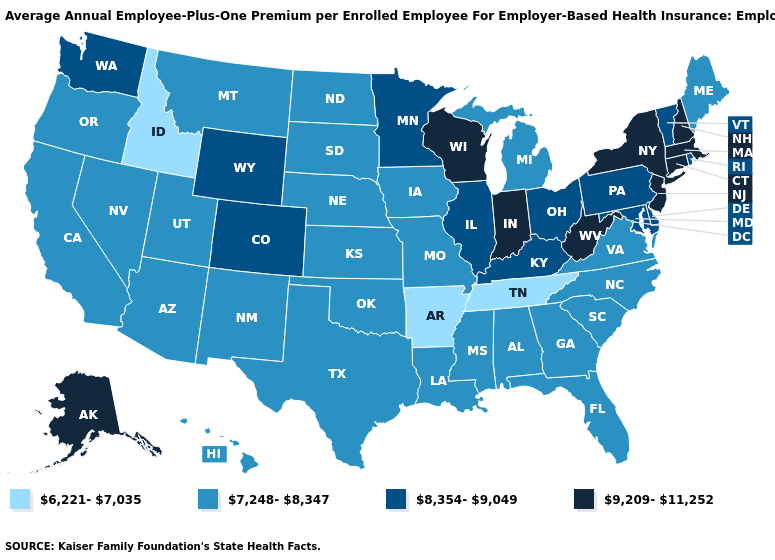Does Arkansas have the same value as Tennessee?
Quick response, please. Yes. What is the highest value in the USA?
Concise answer only. 9,209-11,252. What is the value of Oregon?
Write a very short answer. 7,248-8,347. Which states have the lowest value in the South?
Write a very short answer. Arkansas, Tennessee. Does Idaho have the lowest value in the USA?
Short answer required. Yes. Does Utah have the highest value in the USA?
Quick response, please. No. Which states have the lowest value in the USA?
Short answer required. Arkansas, Idaho, Tennessee. What is the value of Kentucky?
Keep it brief. 8,354-9,049. What is the highest value in the USA?
Keep it brief. 9,209-11,252. Which states have the lowest value in the West?
Answer briefly. Idaho. Does Washington have a lower value than Mississippi?
Keep it brief. No. Name the states that have a value in the range 6,221-7,035?
Write a very short answer. Arkansas, Idaho, Tennessee. What is the value of Hawaii?
Answer briefly. 7,248-8,347. Name the states that have a value in the range 9,209-11,252?
Keep it brief. Alaska, Connecticut, Indiana, Massachusetts, New Hampshire, New Jersey, New York, West Virginia, Wisconsin. Does Indiana have the highest value in the MidWest?
Give a very brief answer. Yes. 